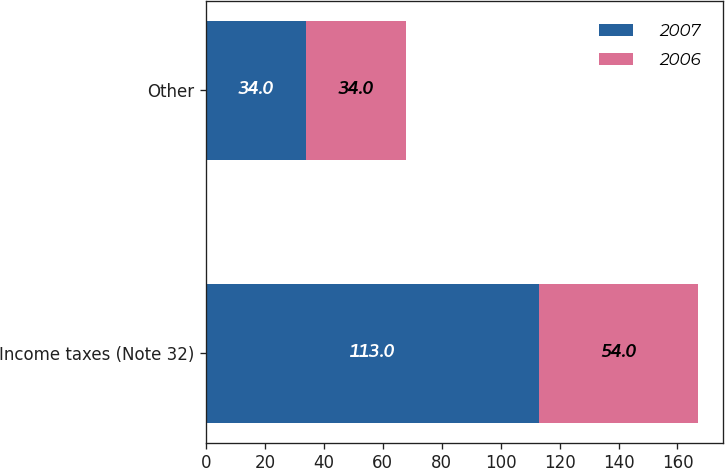Convert chart to OTSL. <chart><loc_0><loc_0><loc_500><loc_500><stacked_bar_chart><ecel><fcel>Income taxes (Note 32)<fcel>Other<nl><fcel>2007<fcel>113<fcel>34<nl><fcel>2006<fcel>54<fcel>34<nl></chart> 